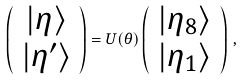<formula> <loc_0><loc_0><loc_500><loc_500>\left ( \begin{array} { c } | \eta \rangle \\ | \eta ^ { \prime } \rangle \end{array} \right ) = U ( \theta ) \left ( \begin{array} { c } | \eta _ { 8 } \rangle \\ | \eta _ { 1 } \rangle \end{array} \right ) \, ,</formula> 